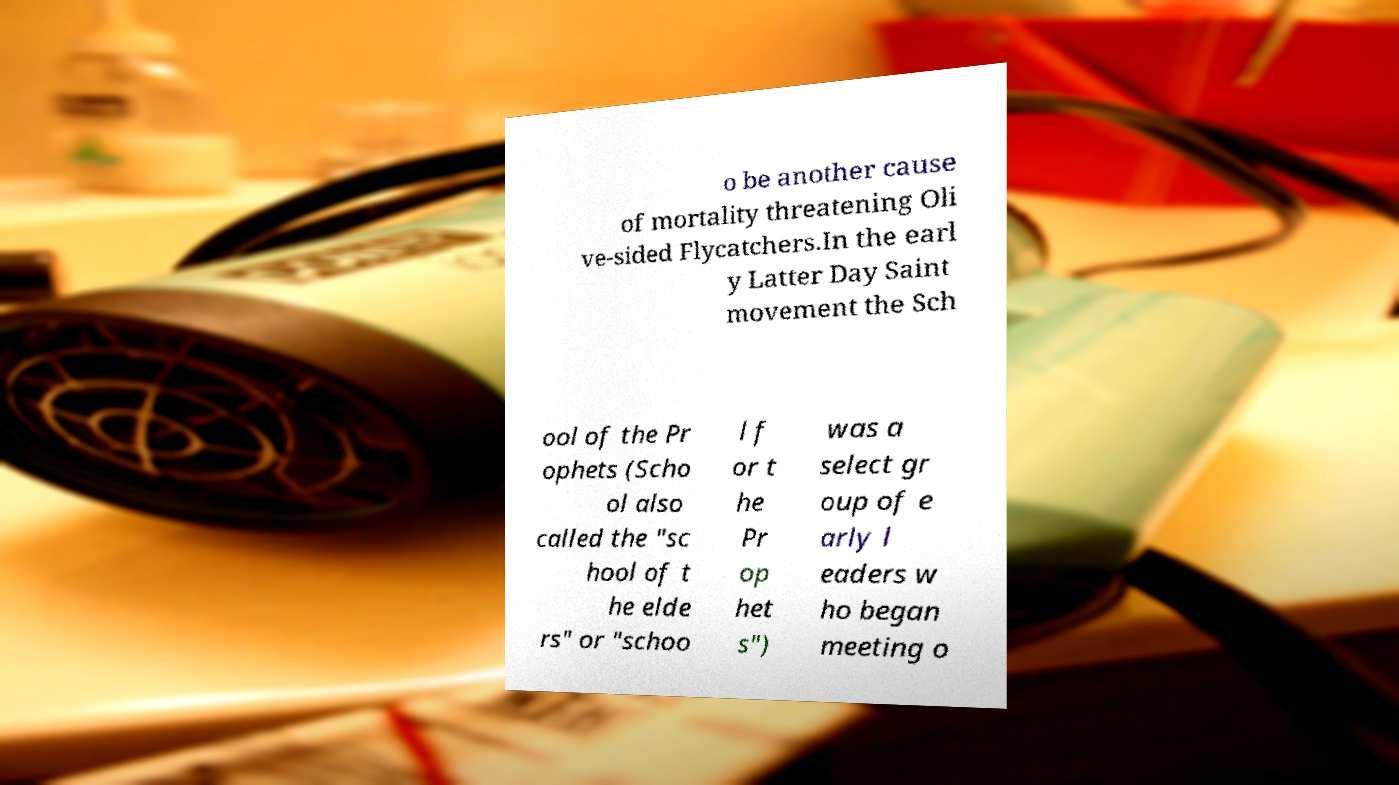For documentation purposes, I need the text within this image transcribed. Could you provide that? o be another cause of mortality threatening Oli ve-sided Flycatchers.In the earl y Latter Day Saint movement the Sch ool of the Pr ophets (Scho ol also called the "sc hool of t he elde rs" or "schoo l f or t he Pr op het s") was a select gr oup of e arly l eaders w ho began meeting o 